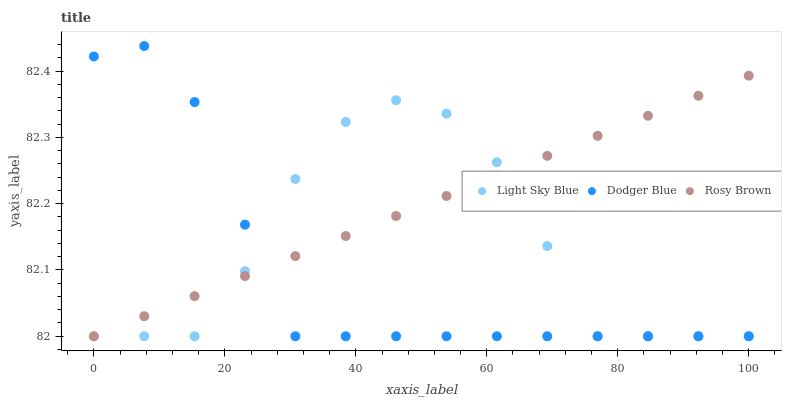Does Dodger Blue have the minimum area under the curve?
Answer yes or no. Yes. Does Rosy Brown have the maximum area under the curve?
Answer yes or no. Yes. Does Light Sky Blue have the minimum area under the curve?
Answer yes or no. No. Does Light Sky Blue have the maximum area under the curve?
Answer yes or no. No. Is Rosy Brown the smoothest?
Answer yes or no. Yes. Is Light Sky Blue the roughest?
Answer yes or no. Yes. Is Dodger Blue the smoothest?
Answer yes or no. No. Is Dodger Blue the roughest?
Answer yes or no. No. Does Rosy Brown have the lowest value?
Answer yes or no. Yes. Does Dodger Blue have the highest value?
Answer yes or no. Yes. Does Light Sky Blue have the highest value?
Answer yes or no. No. Does Dodger Blue intersect Rosy Brown?
Answer yes or no. Yes. Is Dodger Blue less than Rosy Brown?
Answer yes or no. No. Is Dodger Blue greater than Rosy Brown?
Answer yes or no. No. 